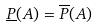<formula> <loc_0><loc_0><loc_500><loc_500>\underline { P } ( A ) = \overline { P } ( A )</formula> 